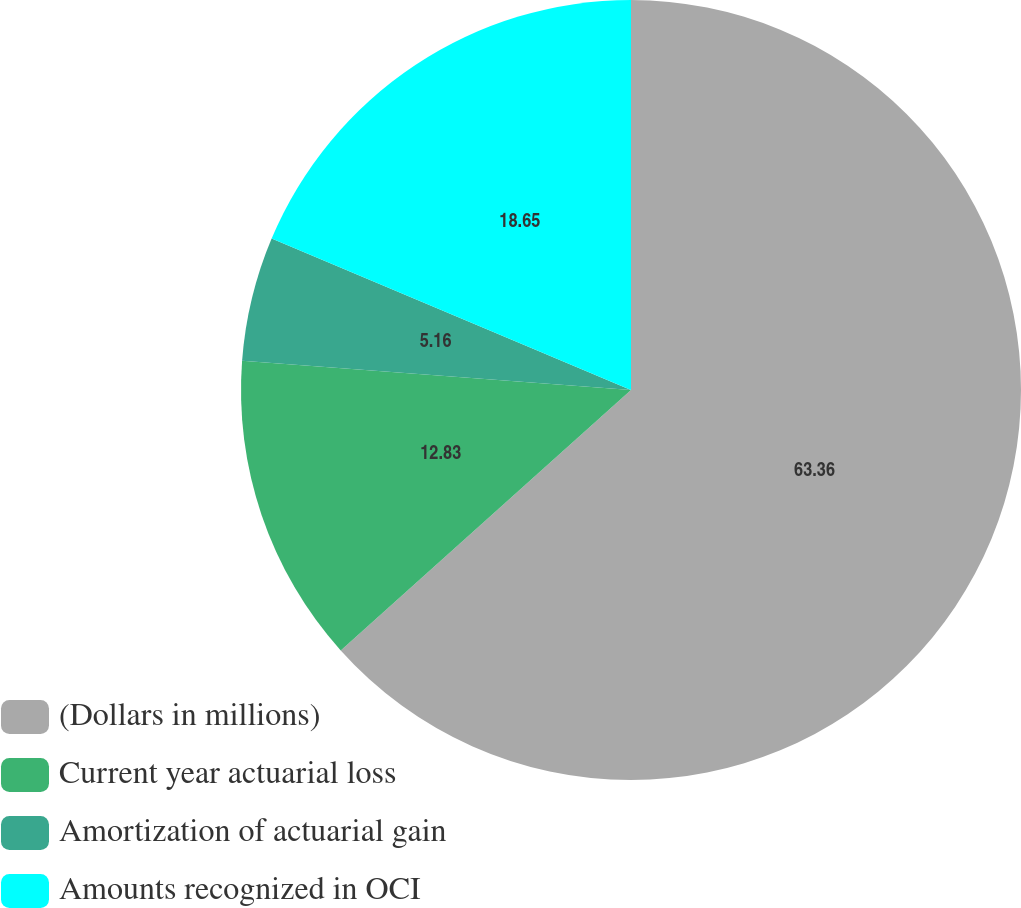Convert chart. <chart><loc_0><loc_0><loc_500><loc_500><pie_chart><fcel>(Dollars in millions)<fcel>Current year actuarial loss<fcel>Amortization of actuarial gain<fcel>Amounts recognized in OCI<nl><fcel>63.36%<fcel>12.83%<fcel>5.16%<fcel>18.65%<nl></chart> 